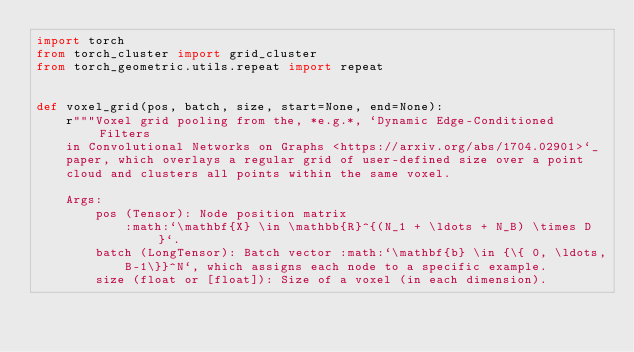Convert code to text. <code><loc_0><loc_0><loc_500><loc_500><_Python_>import torch
from torch_cluster import grid_cluster
from torch_geometric.utils.repeat import repeat


def voxel_grid(pos, batch, size, start=None, end=None):
    r"""Voxel grid pooling from the, *e.g.*, `Dynamic Edge-Conditioned Filters
    in Convolutional Networks on Graphs <https://arxiv.org/abs/1704.02901>`_
    paper, which overlays a regular grid of user-defined size over a point
    cloud and clusters all points within the same voxel.

    Args:
        pos (Tensor): Node position matrix
            :math:`\mathbf{X} \in \mathbb{R}^{(N_1 + \ldots + N_B) \times D}`.
        batch (LongTensor): Batch vector :math:`\mathbf{b} \in {\{ 0, \ldots,
            B-1\}}^N`, which assigns each node to a specific example.
        size (float or [float]): Size of a voxel (in each dimension).</code> 